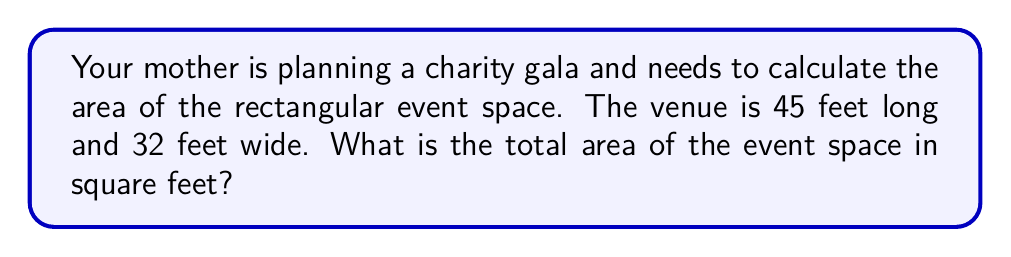Can you solve this math problem? To calculate the area of a rectangular space, we use the formula:

$$A = l \times w$$

Where:
$A$ = Area
$l$ = Length
$w$ = Width

Given:
Length ($l$) = 45 feet
Width ($w$) = 32 feet

Step 1: Substitute the values into the formula
$$A = 45 \times 32$$

Step 2: Multiply
$$A = 1440$$

Therefore, the total area of the event space is 1440 square feet.

[asy]
unitsize(0.1 inch);
draw((0,0)--(45,0)--(45,32)--(0,32)--cycle);
label("45 ft", (22.5,0), S);
label("32 ft", (45,16), E);
label("Area = 1440 sq ft", (22.5,16), black);
[/asy]
Answer: $1440$ sq ft 